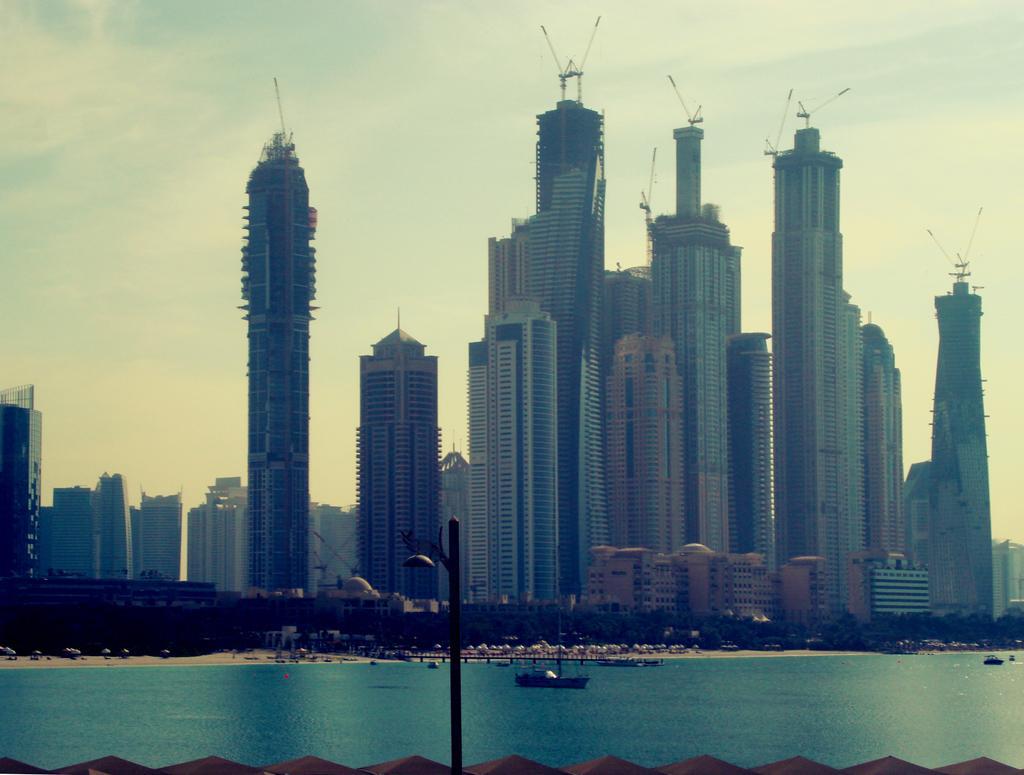In one or two sentences, can you explain what this image depicts? In this image we can see the buildings. We can also see a light pole. Image also consists of boats on the surface of the sea. In the background we can see the sky. 